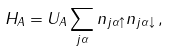<formula> <loc_0><loc_0><loc_500><loc_500>H _ { A } = U _ { A } \sum _ { j \alpha } n _ { j \alpha \uparrow } n _ { j \alpha \downarrow } \, ,</formula> 